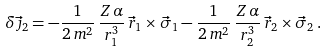<formula> <loc_0><loc_0><loc_500><loc_500>\delta \vec { \jmath } _ { 2 } = - \frac { 1 } { 2 \, m ^ { 2 } } \, \frac { Z \, \alpha } { r _ { 1 } ^ { 3 } } \, \vec { r } _ { 1 } \times \vec { \sigma } _ { 1 } - \frac { 1 } { 2 \, m ^ { 2 } } \, \frac { Z \, \alpha } { r _ { 2 } ^ { 3 } } \, \vec { r } _ { 2 } \times \vec { \sigma } _ { 2 } \, .</formula> 